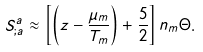<formula> <loc_0><loc_0><loc_500><loc_500>S ^ { a } _ { ; a } \approx \left [ \left ( z - \frac { \mu _ { m } } { T _ { m } } \right ) + \frac { 5 } { 2 } \right ] n _ { m } \Theta .</formula> 